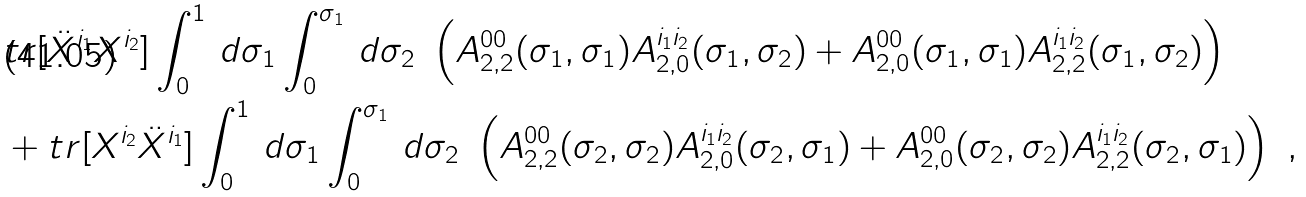<formula> <loc_0><loc_0><loc_500><loc_500>& t r [ \ddot { X } ^ { i _ { 1 } } X ^ { i _ { 2 } } ] \int _ { 0 } ^ { 1 } \, d \sigma _ { 1 } \int _ { 0 } ^ { \sigma _ { 1 } } \, d \sigma _ { 2 } \ \left ( A _ { 2 , 2 } ^ { 0 0 } ( \sigma _ { 1 } , \sigma _ { 1 } ) A _ { 2 , 0 } ^ { i _ { 1 } i _ { 2 } } ( \sigma _ { 1 } , \sigma _ { 2 } ) + A _ { 2 , 0 } ^ { 0 0 } ( \sigma _ { 1 } , \sigma _ { 1 } ) A _ { 2 , 2 } ^ { i _ { 1 } i _ { 2 } } ( \sigma _ { 1 } , \sigma _ { 2 } ) \right ) \\ & + t r [ X ^ { i _ { 2 } } \ddot { X } ^ { i _ { 1 } } ] \int _ { 0 } ^ { 1 } \, d \sigma _ { 1 } \int _ { 0 } ^ { \sigma _ { 1 } } \, d \sigma _ { 2 } \ \left ( A _ { 2 , 2 } ^ { 0 0 } ( \sigma _ { 2 } , \sigma _ { 2 } ) A _ { 2 , 0 } ^ { i _ { 1 } i _ { 2 } } ( \sigma _ { 2 } , \sigma _ { 1 } ) + A _ { 2 , 0 } ^ { 0 0 } ( \sigma _ { 2 } , \sigma _ { 2 } ) A _ { 2 , 2 } ^ { i _ { 1 } i _ { 2 } } ( \sigma _ { 2 } , \sigma _ { 1 } ) \right ) \ ,</formula> 